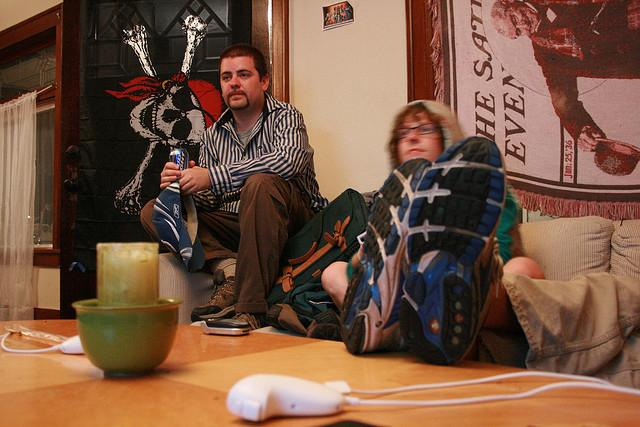What is the man on the left drinking? beer 